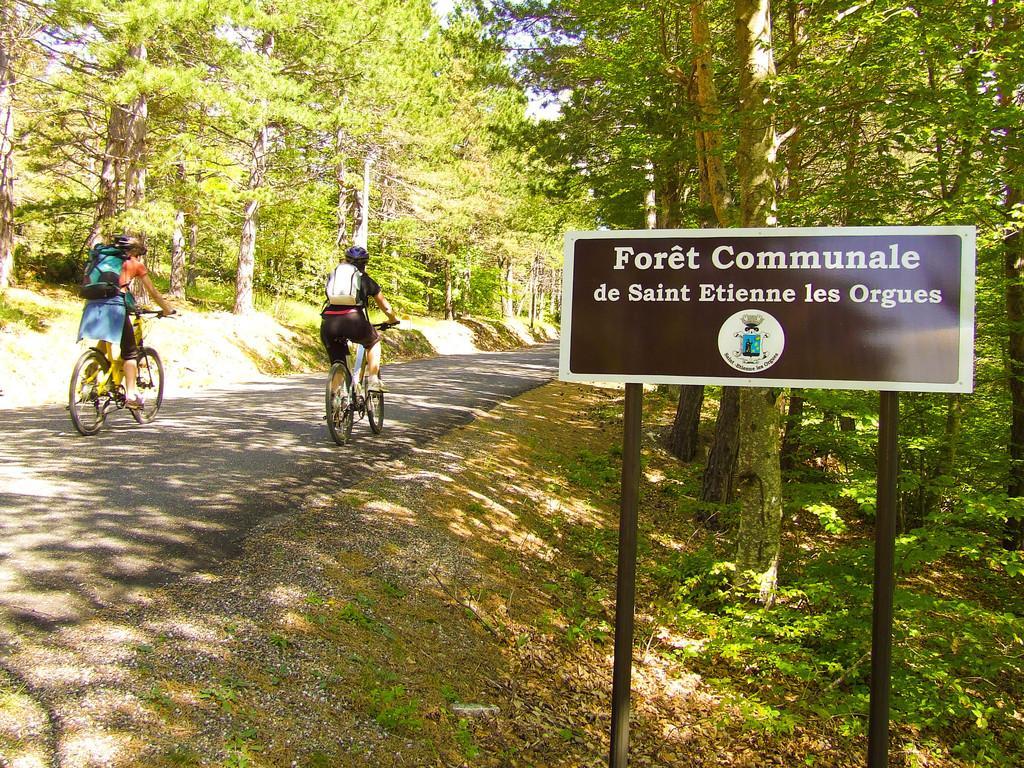Please provide a concise description of this image. In this image we can see two persons wearing the bags and riding the bicycles on the road, there are poles with a board, on the board, we can see some text and an image, also we can see the trees and the sky. 